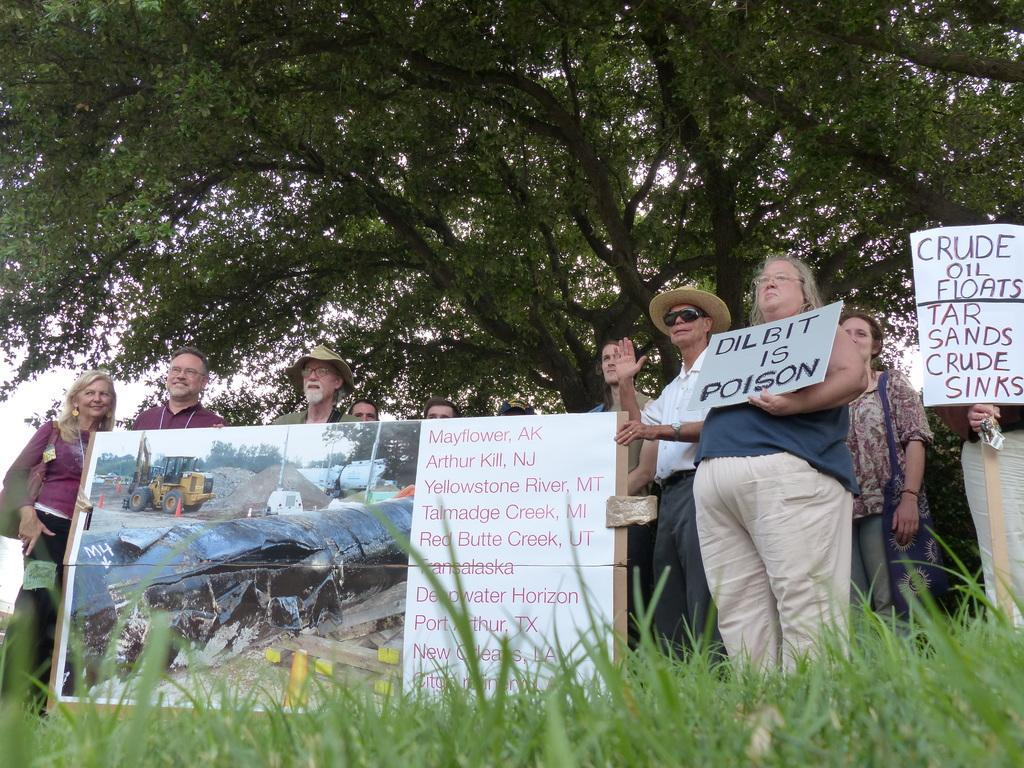What can be seen in the image involving people? There are people standing in the image. What is the woman holding in the image? A woman is holding a board in the image. What type of signage is present in the image? There is a banner in the image. What type of ground surface is visible at the bottom of the image? Grass is visible at the bottom of the image. What type of vegetation can be seen in the background of the image? There is a tree in the background of the image. What type of cake is being served by the servant in the image? There is no cake or servant present in the image. 